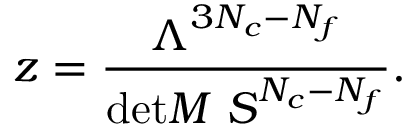Convert formula to latex. <formula><loc_0><loc_0><loc_500><loc_500>z = \frac { \Lambda ^ { 3 N _ { c } - N _ { f } } } { d e t M \ S ^ { N _ { c } - N _ { f } } } .</formula> 